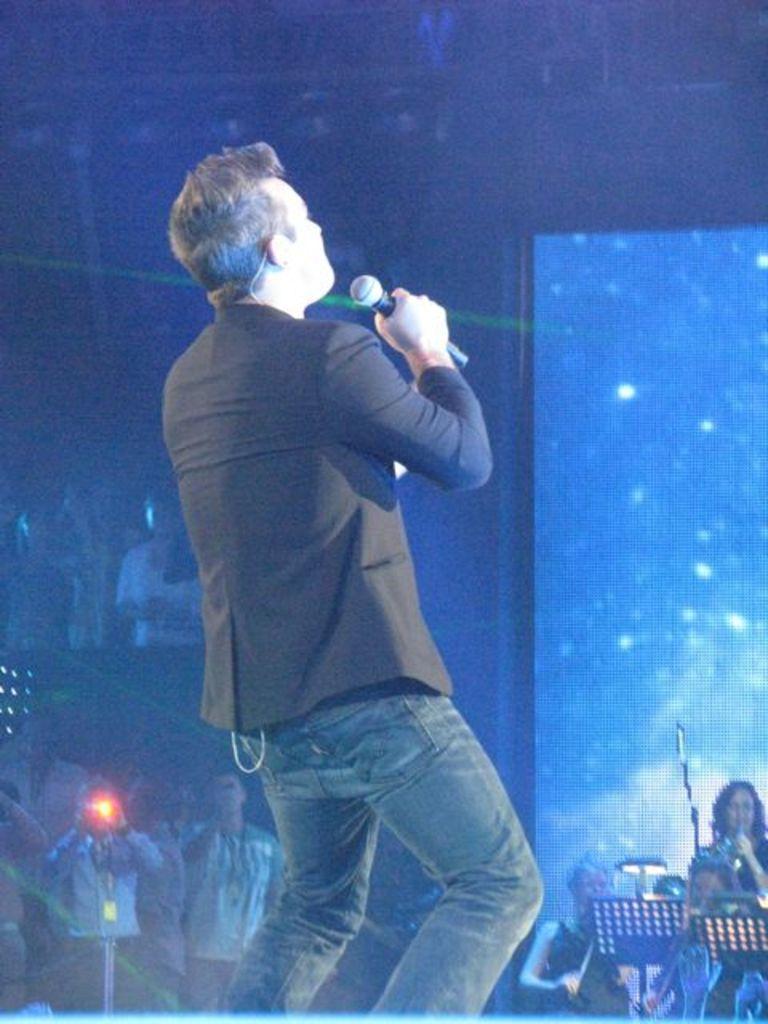In one or two sentences, can you explain what this image depicts? This image is clicked in a musical concert where in the middle a person is wearing black blazer and blue jeans is singing a song. He is holding a mike in his hands. In the right side corner there is a woman sitting and she is holding a mike and singing something. On the left side corner there is a man who has ID called and his clicking some photos, there are lights on the top. 